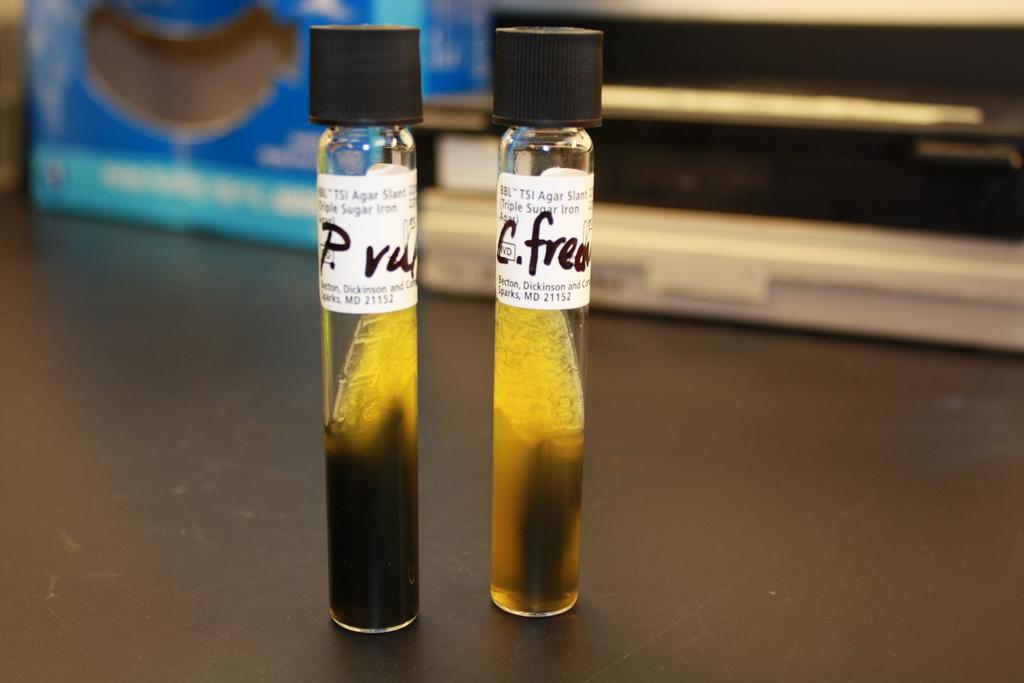What is the first initial on the first tube?
Provide a succinct answer. P. 